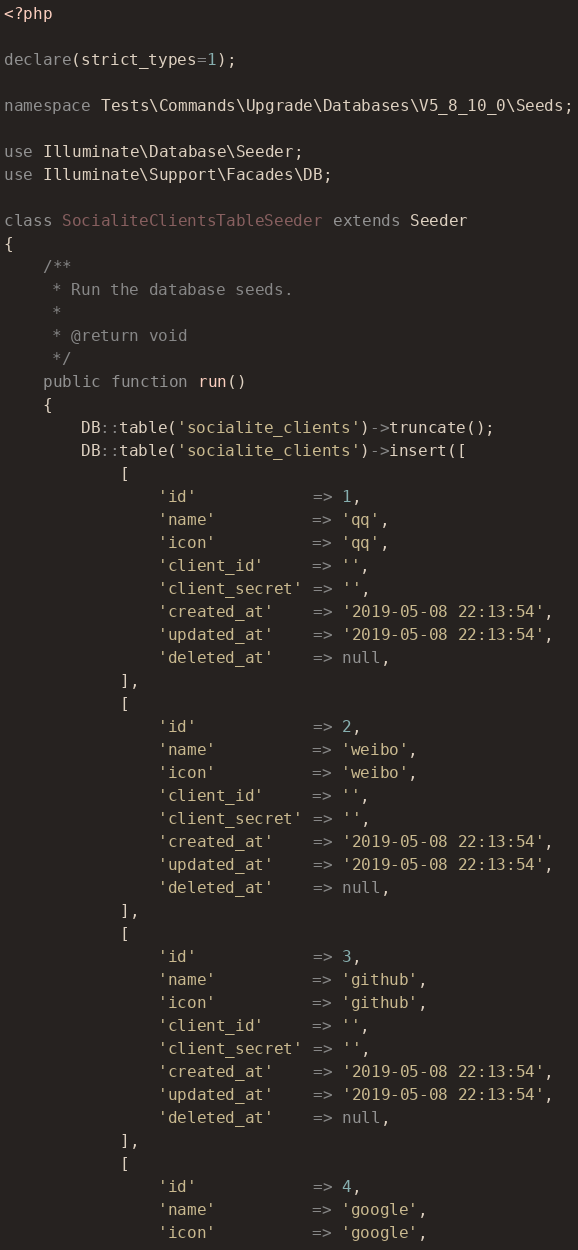Convert code to text. <code><loc_0><loc_0><loc_500><loc_500><_PHP_><?php

declare(strict_types=1);

namespace Tests\Commands\Upgrade\Databases\V5_8_10_0\Seeds;

use Illuminate\Database\Seeder;
use Illuminate\Support\Facades\DB;

class SocialiteClientsTableSeeder extends Seeder
{
    /**
     * Run the database seeds.
     *
     * @return void
     */
    public function run()
    {
        DB::table('socialite_clients')->truncate();
        DB::table('socialite_clients')->insert([
            [
                'id'            => 1,
                'name'          => 'qq',
                'icon'          => 'qq',
                'client_id'     => '',
                'client_secret' => '',
                'created_at'    => '2019-05-08 22:13:54',
                'updated_at'    => '2019-05-08 22:13:54',
                'deleted_at'    => null,
            ],
            [
                'id'            => 2,
                'name'          => 'weibo',
                'icon'          => 'weibo',
                'client_id'     => '',
                'client_secret' => '',
                'created_at'    => '2019-05-08 22:13:54',
                'updated_at'    => '2019-05-08 22:13:54',
                'deleted_at'    => null,
            ],
            [
                'id'            => 3,
                'name'          => 'github',
                'icon'          => 'github',
                'client_id'     => '',
                'client_secret' => '',
                'created_at'    => '2019-05-08 22:13:54',
                'updated_at'    => '2019-05-08 22:13:54',
                'deleted_at'    => null,
            ],
            [
                'id'            => 4,
                'name'          => 'google',
                'icon'          => 'google',</code> 